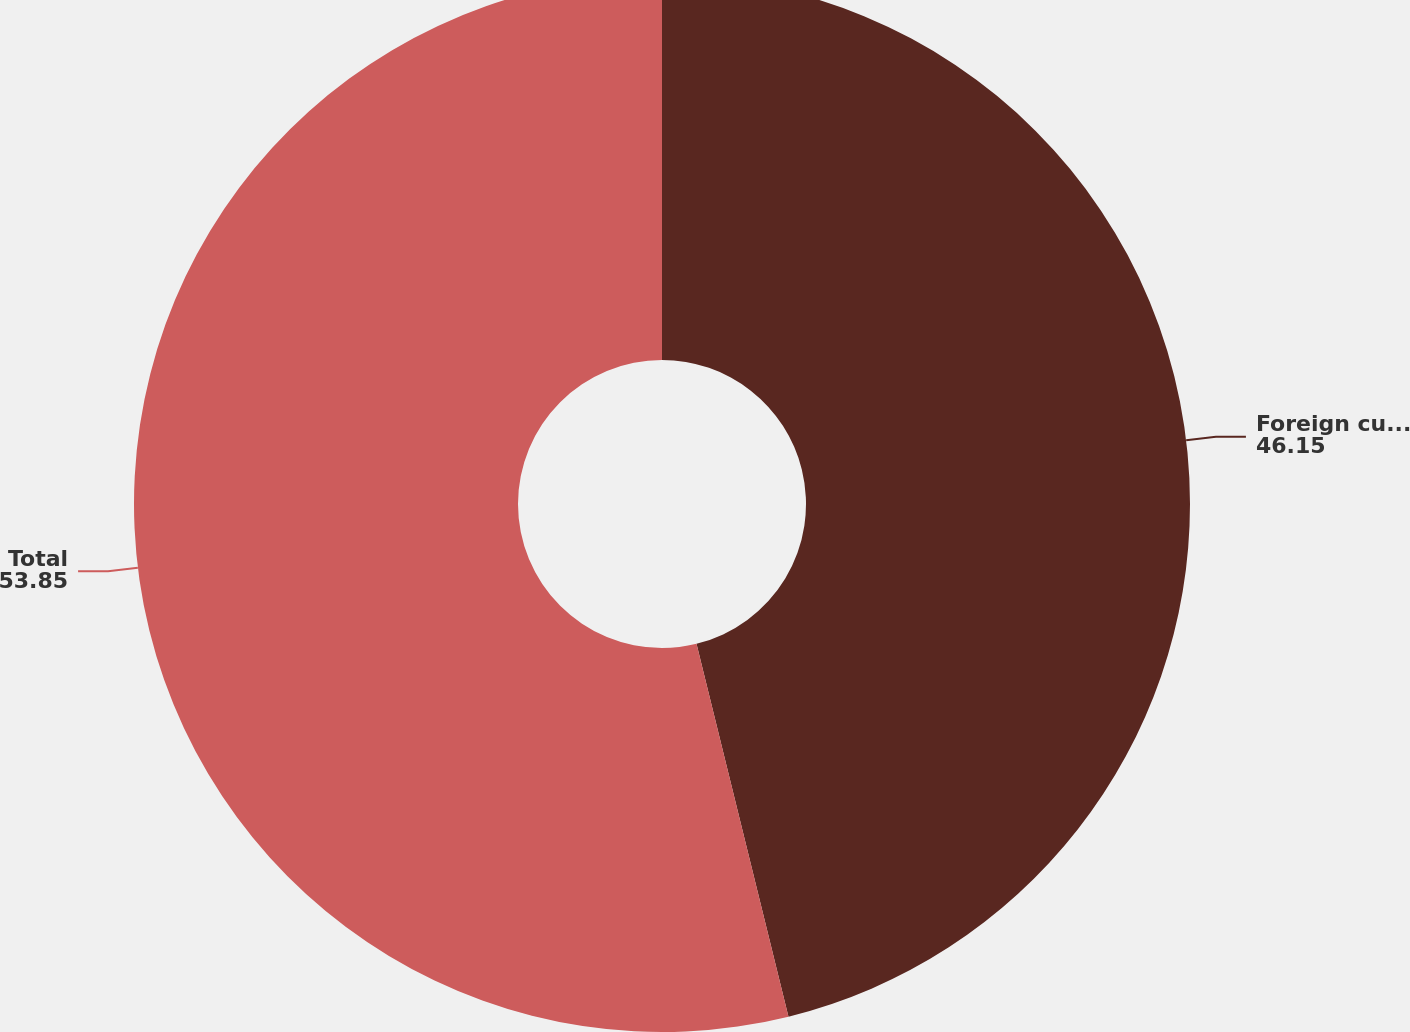<chart> <loc_0><loc_0><loc_500><loc_500><pie_chart><fcel>Foreign currency forward<fcel>Total<nl><fcel>46.15%<fcel>53.85%<nl></chart> 